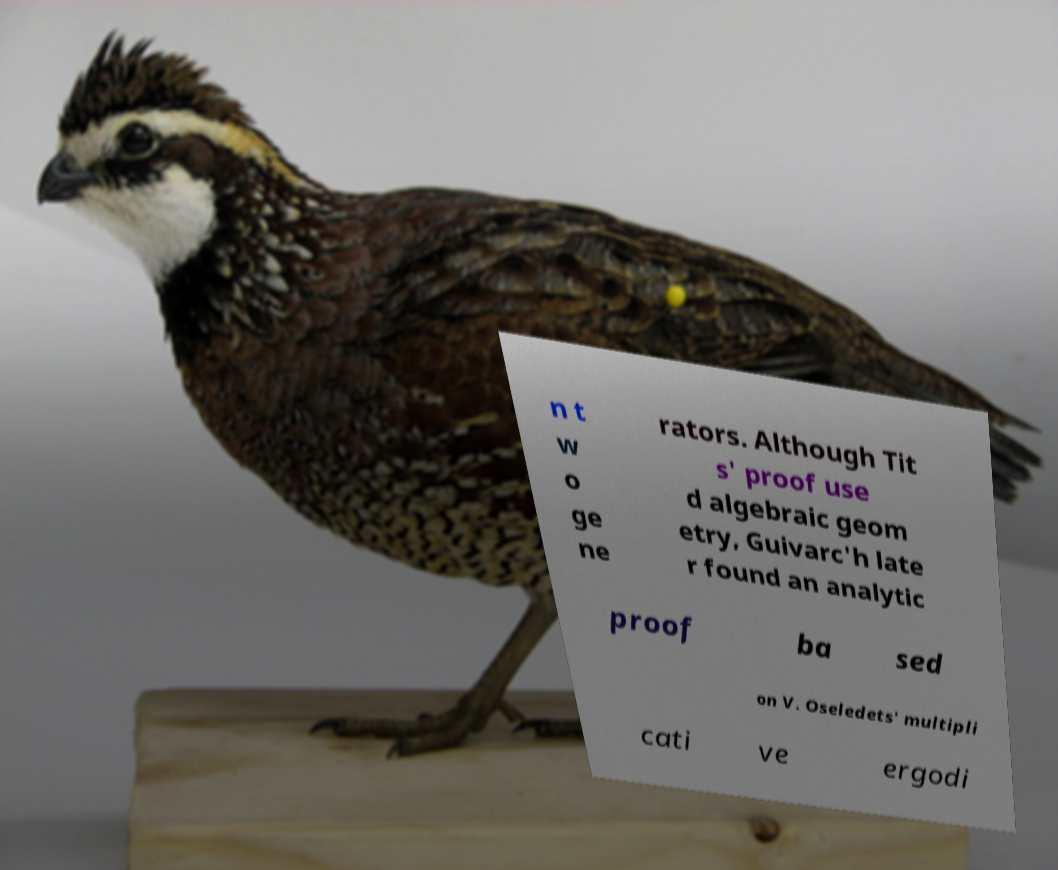Could you assist in decoding the text presented in this image and type it out clearly? n t w o ge ne rators. Although Tit s' proof use d algebraic geom etry, Guivarc'h late r found an analytic proof ba sed on V. Oseledets' multipli cati ve ergodi 